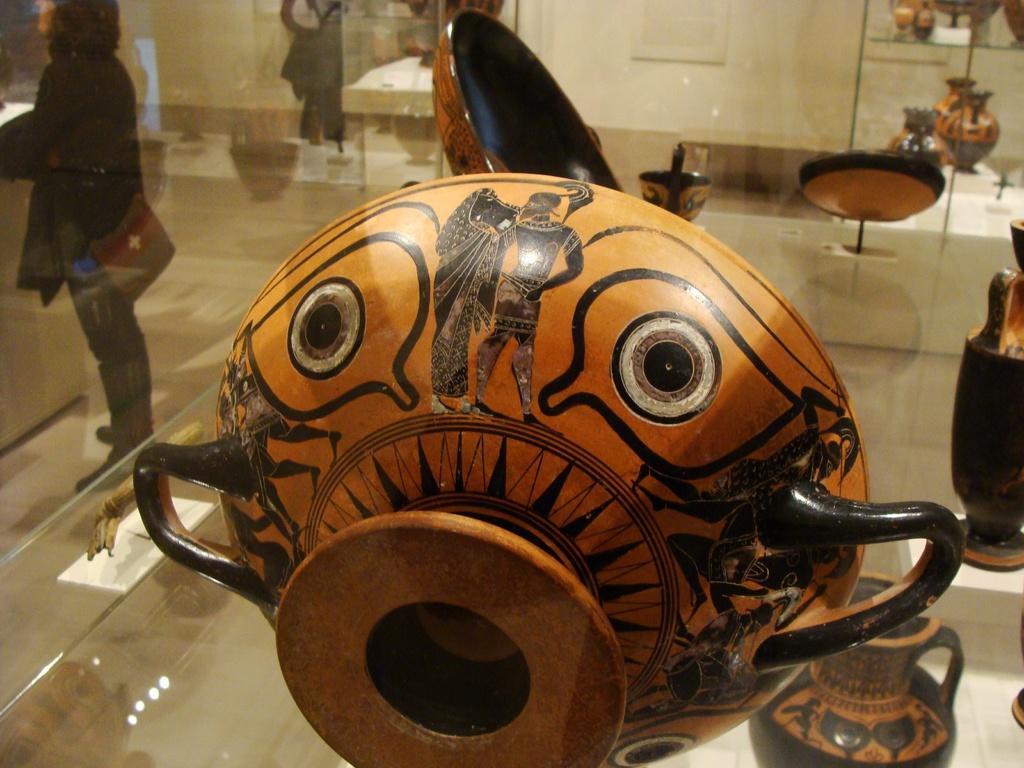In one or two sentences, can you explain what this image depicts? This image consists of a bowl. It looks like it is made up of ceramic. And there are many objects which looks like those are made up of ceramic. On the left, we can see a woman standing. At the bottom, there is a floor. 